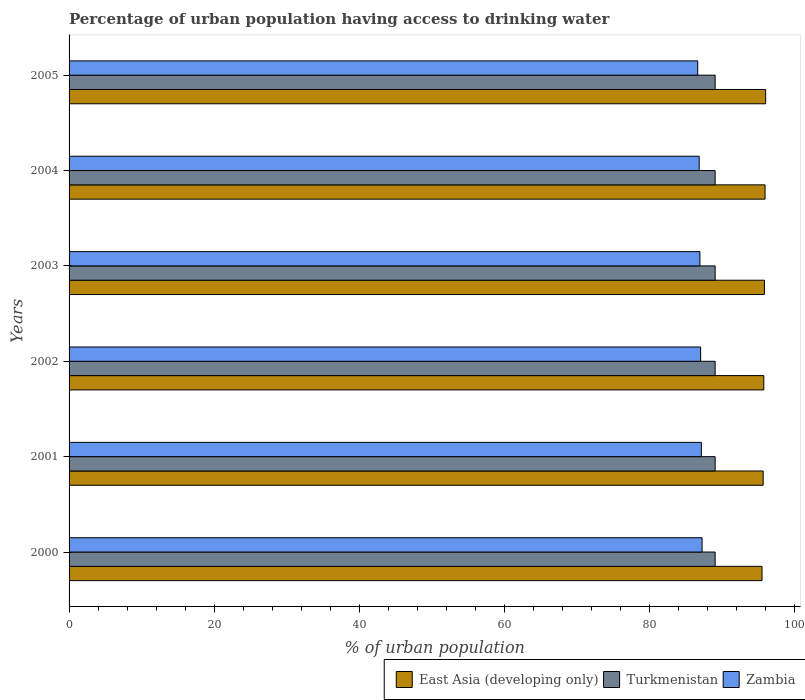How many different coloured bars are there?
Make the answer very short. 3. How many groups of bars are there?
Provide a succinct answer. 6. Are the number of bars per tick equal to the number of legend labels?
Give a very brief answer. Yes. Are the number of bars on each tick of the Y-axis equal?
Give a very brief answer. Yes. How many bars are there on the 3rd tick from the bottom?
Make the answer very short. 3. What is the label of the 3rd group of bars from the top?
Provide a short and direct response. 2003. In how many cases, is the number of bars for a given year not equal to the number of legend labels?
Offer a terse response. 0. What is the percentage of urban population having access to drinking water in Zambia in 2001?
Ensure brevity in your answer.  87.2. Across all years, what is the maximum percentage of urban population having access to drinking water in Zambia?
Provide a short and direct response. 87.3. Across all years, what is the minimum percentage of urban population having access to drinking water in Turkmenistan?
Give a very brief answer. 89.1. What is the total percentage of urban population having access to drinking water in East Asia (developing only) in the graph?
Keep it short and to the point. 575.06. What is the difference between the percentage of urban population having access to drinking water in Turkmenistan in 2000 and that in 2005?
Offer a very short reply. 0. What is the difference between the percentage of urban population having access to drinking water in East Asia (developing only) in 2001 and the percentage of urban population having access to drinking water in Zambia in 2003?
Offer a terse response. 8.72. What is the average percentage of urban population having access to drinking water in Turkmenistan per year?
Offer a very short reply. 89.1. In the year 2002, what is the difference between the percentage of urban population having access to drinking water in Zambia and percentage of urban population having access to drinking water in Turkmenistan?
Make the answer very short. -2. In how many years, is the percentage of urban population having access to drinking water in Turkmenistan greater than 96 %?
Offer a terse response. 0. What is the ratio of the percentage of urban population having access to drinking water in Zambia in 2003 to that in 2004?
Provide a short and direct response. 1. Is the percentage of urban population having access to drinking water in East Asia (developing only) in 2003 less than that in 2005?
Your answer should be compact. Yes. Is the difference between the percentage of urban population having access to drinking water in Zambia in 2002 and 2003 greater than the difference between the percentage of urban population having access to drinking water in Turkmenistan in 2002 and 2003?
Offer a very short reply. Yes. What is the difference between the highest and the second highest percentage of urban population having access to drinking water in Zambia?
Your answer should be compact. 0.1. What is the difference between the highest and the lowest percentage of urban population having access to drinking water in Turkmenistan?
Provide a succinct answer. 0. Is the sum of the percentage of urban population having access to drinking water in East Asia (developing only) in 2001 and 2003 greater than the maximum percentage of urban population having access to drinking water in Turkmenistan across all years?
Your answer should be very brief. Yes. What does the 3rd bar from the top in 2003 represents?
Provide a short and direct response. East Asia (developing only). What does the 3rd bar from the bottom in 2000 represents?
Offer a very short reply. Zambia. Are all the bars in the graph horizontal?
Keep it short and to the point. Yes. How many years are there in the graph?
Your answer should be very brief. 6. Are the values on the major ticks of X-axis written in scientific E-notation?
Make the answer very short. No. Does the graph contain any zero values?
Provide a succinct answer. No. Where does the legend appear in the graph?
Offer a very short reply. Bottom right. How many legend labels are there?
Keep it short and to the point. 3. How are the legend labels stacked?
Provide a short and direct response. Horizontal. What is the title of the graph?
Keep it short and to the point. Percentage of urban population having access to drinking water. Does "Serbia" appear as one of the legend labels in the graph?
Your answer should be compact. No. What is the label or title of the X-axis?
Your answer should be very brief. % of urban population. What is the % of urban population in East Asia (developing only) in 2000?
Give a very brief answer. 95.57. What is the % of urban population of Turkmenistan in 2000?
Make the answer very short. 89.1. What is the % of urban population in Zambia in 2000?
Provide a short and direct response. 87.3. What is the % of urban population in East Asia (developing only) in 2001?
Offer a terse response. 95.72. What is the % of urban population of Turkmenistan in 2001?
Your answer should be very brief. 89.1. What is the % of urban population of Zambia in 2001?
Your response must be concise. 87.2. What is the % of urban population in East Asia (developing only) in 2002?
Your answer should be compact. 95.81. What is the % of urban population of Turkmenistan in 2002?
Your answer should be compact. 89.1. What is the % of urban population in Zambia in 2002?
Give a very brief answer. 87.1. What is the % of urban population in East Asia (developing only) in 2003?
Offer a terse response. 95.9. What is the % of urban population of Turkmenistan in 2003?
Your response must be concise. 89.1. What is the % of urban population in East Asia (developing only) in 2004?
Your response must be concise. 95.98. What is the % of urban population of Turkmenistan in 2004?
Give a very brief answer. 89.1. What is the % of urban population in Zambia in 2004?
Ensure brevity in your answer.  86.9. What is the % of urban population of East Asia (developing only) in 2005?
Offer a terse response. 96.07. What is the % of urban population in Turkmenistan in 2005?
Provide a short and direct response. 89.1. What is the % of urban population in Zambia in 2005?
Keep it short and to the point. 86.7. Across all years, what is the maximum % of urban population of East Asia (developing only)?
Your answer should be very brief. 96.07. Across all years, what is the maximum % of urban population in Turkmenistan?
Your answer should be very brief. 89.1. Across all years, what is the maximum % of urban population in Zambia?
Provide a succinct answer. 87.3. Across all years, what is the minimum % of urban population in East Asia (developing only)?
Ensure brevity in your answer.  95.57. Across all years, what is the minimum % of urban population in Turkmenistan?
Give a very brief answer. 89.1. Across all years, what is the minimum % of urban population of Zambia?
Your response must be concise. 86.7. What is the total % of urban population of East Asia (developing only) in the graph?
Your response must be concise. 575.06. What is the total % of urban population of Turkmenistan in the graph?
Provide a succinct answer. 534.6. What is the total % of urban population of Zambia in the graph?
Ensure brevity in your answer.  522.2. What is the difference between the % of urban population of East Asia (developing only) in 2000 and that in 2001?
Your answer should be compact. -0.16. What is the difference between the % of urban population of East Asia (developing only) in 2000 and that in 2002?
Keep it short and to the point. -0.25. What is the difference between the % of urban population in Turkmenistan in 2000 and that in 2002?
Provide a succinct answer. 0. What is the difference between the % of urban population in Zambia in 2000 and that in 2002?
Keep it short and to the point. 0.2. What is the difference between the % of urban population in East Asia (developing only) in 2000 and that in 2003?
Offer a very short reply. -0.33. What is the difference between the % of urban population of East Asia (developing only) in 2000 and that in 2004?
Your answer should be compact. -0.42. What is the difference between the % of urban population of Turkmenistan in 2000 and that in 2004?
Keep it short and to the point. 0. What is the difference between the % of urban population of East Asia (developing only) in 2000 and that in 2005?
Make the answer very short. -0.5. What is the difference between the % of urban population of Turkmenistan in 2000 and that in 2005?
Provide a succinct answer. 0. What is the difference between the % of urban population in East Asia (developing only) in 2001 and that in 2002?
Your answer should be compact. -0.09. What is the difference between the % of urban population in Turkmenistan in 2001 and that in 2002?
Ensure brevity in your answer.  0. What is the difference between the % of urban population in Zambia in 2001 and that in 2002?
Your answer should be very brief. 0.1. What is the difference between the % of urban population in East Asia (developing only) in 2001 and that in 2003?
Make the answer very short. -0.18. What is the difference between the % of urban population of East Asia (developing only) in 2001 and that in 2004?
Provide a succinct answer. -0.26. What is the difference between the % of urban population of East Asia (developing only) in 2001 and that in 2005?
Ensure brevity in your answer.  -0.35. What is the difference between the % of urban population of Turkmenistan in 2001 and that in 2005?
Your answer should be compact. 0. What is the difference between the % of urban population in East Asia (developing only) in 2002 and that in 2003?
Ensure brevity in your answer.  -0.08. What is the difference between the % of urban population in Turkmenistan in 2002 and that in 2003?
Keep it short and to the point. 0. What is the difference between the % of urban population of East Asia (developing only) in 2002 and that in 2004?
Your answer should be very brief. -0.17. What is the difference between the % of urban population in East Asia (developing only) in 2002 and that in 2005?
Make the answer very short. -0.25. What is the difference between the % of urban population in East Asia (developing only) in 2003 and that in 2004?
Your answer should be very brief. -0.09. What is the difference between the % of urban population of East Asia (developing only) in 2003 and that in 2005?
Provide a succinct answer. -0.17. What is the difference between the % of urban population of Zambia in 2003 and that in 2005?
Offer a very short reply. 0.3. What is the difference between the % of urban population in East Asia (developing only) in 2004 and that in 2005?
Provide a short and direct response. -0.08. What is the difference between the % of urban population in Turkmenistan in 2004 and that in 2005?
Give a very brief answer. 0. What is the difference between the % of urban population of Zambia in 2004 and that in 2005?
Keep it short and to the point. 0.2. What is the difference between the % of urban population of East Asia (developing only) in 2000 and the % of urban population of Turkmenistan in 2001?
Provide a succinct answer. 6.47. What is the difference between the % of urban population in East Asia (developing only) in 2000 and the % of urban population in Zambia in 2001?
Provide a succinct answer. 8.37. What is the difference between the % of urban population in East Asia (developing only) in 2000 and the % of urban population in Turkmenistan in 2002?
Provide a short and direct response. 6.47. What is the difference between the % of urban population of East Asia (developing only) in 2000 and the % of urban population of Zambia in 2002?
Ensure brevity in your answer.  8.47. What is the difference between the % of urban population of Turkmenistan in 2000 and the % of urban population of Zambia in 2002?
Your answer should be very brief. 2. What is the difference between the % of urban population of East Asia (developing only) in 2000 and the % of urban population of Turkmenistan in 2003?
Offer a very short reply. 6.47. What is the difference between the % of urban population of East Asia (developing only) in 2000 and the % of urban population of Zambia in 2003?
Your response must be concise. 8.57. What is the difference between the % of urban population in East Asia (developing only) in 2000 and the % of urban population in Turkmenistan in 2004?
Your answer should be compact. 6.47. What is the difference between the % of urban population of East Asia (developing only) in 2000 and the % of urban population of Zambia in 2004?
Your response must be concise. 8.67. What is the difference between the % of urban population of East Asia (developing only) in 2000 and the % of urban population of Turkmenistan in 2005?
Your response must be concise. 6.47. What is the difference between the % of urban population in East Asia (developing only) in 2000 and the % of urban population in Zambia in 2005?
Offer a terse response. 8.87. What is the difference between the % of urban population in Turkmenistan in 2000 and the % of urban population in Zambia in 2005?
Give a very brief answer. 2.4. What is the difference between the % of urban population in East Asia (developing only) in 2001 and the % of urban population in Turkmenistan in 2002?
Provide a short and direct response. 6.62. What is the difference between the % of urban population in East Asia (developing only) in 2001 and the % of urban population in Zambia in 2002?
Ensure brevity in your answer.  8.62. What is the difference between the % of urban population in Turkmenistan in 2001 and the % of urban population in Zambia in 2002?
Your answer should be very brief. 2. What is the difference between the % of urban population of East Asia (developing only) in 2001 and the % of urban population of Turkmenistan in 2003?
Your answer should be very brief. 6.62. What is the difference between the % of urban population in East Asia (developing only) in 2001 and the % of urban population in Zambia in 2003?
Offer a terse response. 8.72. What is the difference between the % of urban population of East Asia (developing only) in 2001 and the % of urban population of Turkmenistan in 2004?
Make the answer very short. 6.62. What is the difference between the % of urban population in East Asia (developing only) in 2001 and the % of urban population in Zambia in 2004?
Your answer should be very brief. 8.82. What is the difference between the % of urban population of Turkmenistan in 2001 and the % of urban population of Zambia in 2004?
Offer a terse response. 2.2. What is the difference between the % of urban population of East Asia (developing only) in 2001 and the % of urban population of Turkmenistan in 2005?
Your answer should be very brief. 6.62. What is the difference between the % of urban population of East Asia (developing only) in 2001 and the % of urban population of Zambia in 2005?
Offer a terse response. 9.02. What is the difference between the % of urban population of East Asia (developing only) in 2002 and the % of urban population of Turkmenistan in 2003?
Keep it short and to the point. 6.71. What is the difference between the % of urban population of East Asia (developing only) in 2002 and the % of urban population of Zambia in 2003?
Make the answer very short. 8.81. What is the difference between the % of urban population in Turkmenistan in 2002 and the % of urban population in Zambia in 2003?
Provide a short and direct response. 2.1. What is the difference between the % of urban population of East Asia (developing only) in 2002 and the % of urban population of Turkmenistan in 2004?
Offer a terse response. 6.71. What is the difference between the % of urban population of East Asia (developing only) in 2002 and the % of urban population of Zambia in 2004?
Make the answer very short. 8.91. What is the difference between the % of urban population in East Asia (developing only) in 2002 and the % of urban population in Turkmenistan in 2005?
Provide a short and direct response. 6.71. What is the difference between the % of urban population of East Asia (developing only) in 2002 and the % of urban population of Zambia in 2005?
Provide a succinct answer. 9.11. What is the difference between the % of urban population of East Asia (developing only) in 2003 and the % of urban population of Turkmenistan in 2004?
Your answer should be compact. 6.8. What is the difference between the % of urban population in East Asia (developing only) in 2003 and the % of urban population in Zambia in 2004?
Keep it short and to the point. 9. What is the difference between the % of urban population of Turkmenistan in 2003 and the % of urban population of Zambia in 2004?
Keep it short and to the point. 2.2. What is the difference between the % of urban population in East Asia (developing only) in 2003 and the % of urban population in Turkmenistan in 2005?
Offer a terse response. 6.8. What is the difference between the % of urban population in East Asia (developing only) in 2003 and the % of urban population in Zambia in 2005?
Offer a very short reply. 9.2. What is the difference between the % of urban population of Turkmenistan in 2003 and the % of urban population of Zambia in 2005?
Provide a short and direct response. 2.4. What is the difference between the % of urban population in East Asia (developing only) in 2004 and the % of urban population in Turkmenistan in 2005?
Provide a short and direct response. 6.88. What is the difference between the % of urban population of East Asia (developing only) in 2004 and the % of urban population of Zambia in 2005?
Offer a terse response. 9.28. What is the average % of urban population of East Asia (developing only) per year?
Ensure brevity in your answer.  95.84. What is the average % of urban population in Turkmenistan per year?
Your response must be concise. 89.1. What is the average % of urban population in Zambia per year?
Your answer should be very brief. 87.03. In the year 2000, what is the difference between the % of urban population of East Asia (developing only) and % of urban population of Turkmenistan?
Provide a succinct answer. 6.47. In the year 2000, what is the difference between the % of urban population in East Asia (developing only) and % of urban population in Zambia?
Offer a very short reply. 8.27. In the year 2000, what is the difference between the % of urban population in Turkmenistan and % of urban population in Zambia?
Your answer should be very brief. 1.8. In the year 2001, what is the difference between the % of urban population in East Asia (developing only) and % of urban population in Turkmenistan?
Provide a succinct answer. 6.62. In the year 2001, what is the difference between the % of urban population in East Asia (developing only) and % of urban population in Zambia?
Your response must be concise. 8.52. In the year 2002, what is the difference between the % of urban population in East Asia (developing only) and % of urban population in Turkmenistan?
Provide a succinct answer. 6.71. In the year 2002, what is the difference between the % of urban population of East Asia (developing only) and % of urban population of Zambia?
Your response must be concise. 8.71. In the year 2002, what is the difference between the % of urban population in Turkmenistan and % of urban population in Zambia?
Offer a very short reply. 2. In the year 2003, what is the difference between the % of urban population in East Asia (developing only) and % of urban population in Turkmenistan?
Give a very brief answer. 6.8. In the year 2003, what is the difference between the % of urban population in East Asia (developing only) and % of urban population in Zambia?
Your response must be concise. 8.9. In the year 2004, what is the difference between the % of urban population in East Asia (developing only) and % of urban population in Turkmenistan?
Your answer should be compact. 6.88. In the year 2004, what is the difference between the % of urban population in East Asia (developing only) and % of urban population in Zambia?
Provide a short and direct response. 9.08. In the year 2004, what is the difference between the % of urban population of Turkmenistan and % of urban population of Zambia?
Provide a short and direct response. 2.2. In the year 2005, what is the difference between the % of urban population in East Asia (developing only) and % of urban population in Turkmenistan?
Make the answer very short. 6.97. In the year 2005, what is the difference between the % of urban population in East Asia (developing only) and % of urban population in Zambia?
Make the answer very short. 9.37. What is the ratio of the % of urban population in Turkmenistan in 2000 to that in 2001?
Offer a terse response. 1. What is the ratio of the % of urban population in Zambia in 2000 to that in 2003?
Your answer should be compact. 1. What is the ratio of the % of urban population of East Asia (developing only) in 2000 to that in 2004?
Offer a terse response. 1. What is the ratio of the % of urban population in Turkmenistan in 2000 to that in 2004?
Provide a short and direct response. 1. What is the ratio of the % of urban population in Zambia in 2000 to that in 2004?
Offer a terse response. 1. What is the ratio of the % of urban population in East Asia (developing only) in 2000 to that in 2005?
Offer a very short reply. 0.99. What is the ratio of the % of urban population of East Asia (developing only) in 2001 to that in 2002?
Offer a very short reply. 1. What is the ratio of the % of urban population of Turkmenistan in 2001 to that in 2003?
Offer a terse response. 1. What is the ratio of the % of urban population in Zambia in 2001 to that in 2003?
Ensure brevity in your answer.  1. What is the ratio of the % of urban population of East Asia (developing only) in 2001 to that in 2004?
Provide a short and direct response. 1. What is the ratio of the % of urban population of Zambia in 2001 to that in 2004?
Your answer should be very brief. 1. What is the ratio of the % of urban population of East Asia (developing only) in 2001 to that in 2005?
Provide a short and direct response. 1. What is the ratio of the % of urban population in Turkmenistan in 2001 to that in 2005?
Ensure brevity in your answer.  1. What is the ratio of the % of urban population of Zambia in 2001 to that in 2005?
Provide a succinct answer. 1.01. What is the ratio of the % of urban population of Zambia in 2002 to that in 2004?
Your answer should be compact. 1. What is the ratio of the % of urban population in East Asia (developing only) in 2003 to that in 2004?
Ensure brevity in your answer.  1. What is the difference between the highest and the second highest % of urban population of East Asia (developing only)?
Provide a short and direct response. 0.08. What is the difference between the highest and the second highest % of urban population of Zambia?
Your answer should be compact. 0.1. What is the difference between the highest and the lowest % of urban population in East Asia (developing only)?
Offer a terse response. 0.5. 